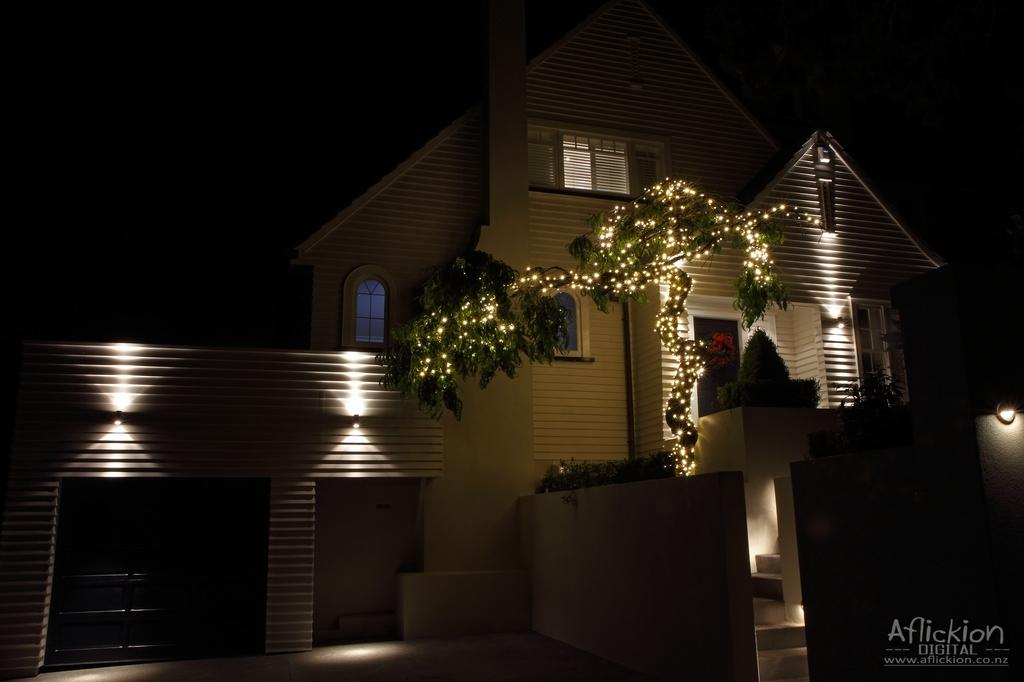What type of structure is present in the image? There is a house in the image. What feature of the house is mentioned in the facts? The house has windows. What other object can be seen in the image? There is a plant visible in the image. What can be seen inside the house? There are lights visible in the image. How would you describe the sky in the image? The sky appears to be dark in the image. Is there any additional information about the image itself? There is a watermark in the bottom right corner of the image. What type of beam is being used to hammer a cushion in the image? There is no beam, hammer, or cushion present in the image. 